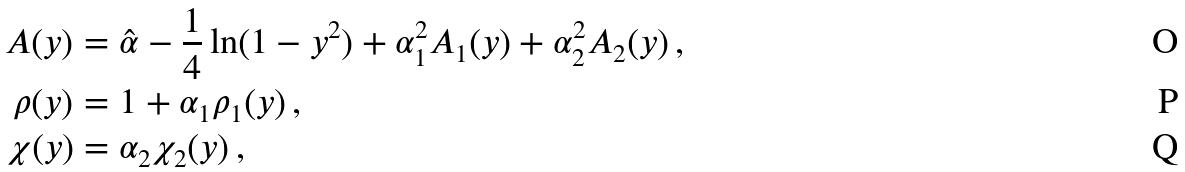<formula> <loc_0><loc_0><loc_500><loc_500>A ( y ) & = { \hat { \alpha } } - \frac { 1 } { 4 } \ln ( 1 - y ^ { 2 } ) + \alpha _ { 1 } ^ { 2 } A _ { 1 } ( y ) + \alpha _ { 2 } ^ { 2 } A _ { 2 } ( y ) \, , \\ \rho ( y ) & = 1 + \alpha _ { 1 } \rho _ { 1 } ( y ) \, , \\ \chi ( y ) & = \alpha _ { 2 } \chi _ { 2 } ( y ) \, ,</formula> 